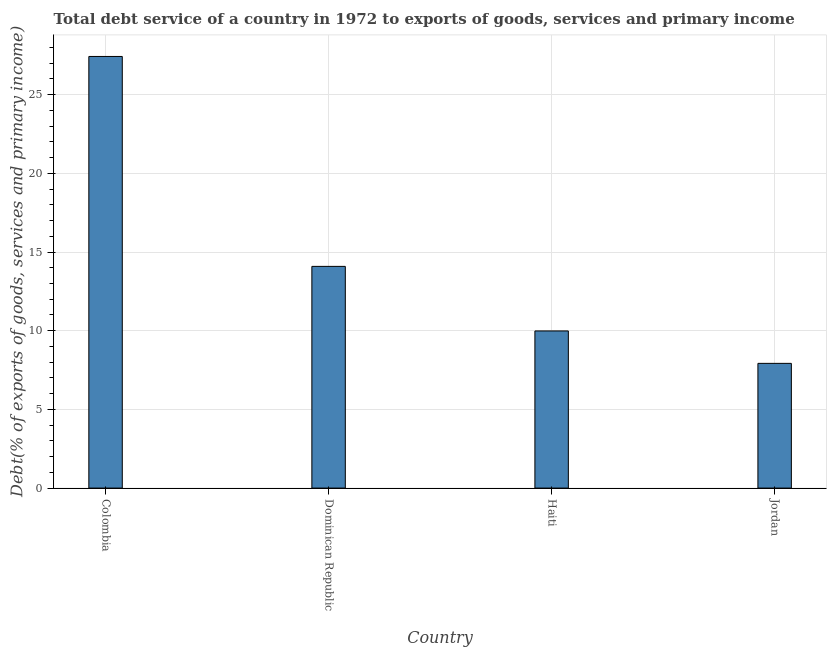Does the graph contain any zero values?
Provide a succinct answer. No. What is the title of the graph?
Make the answer very short. Total debt service of a country in 1972 to exports of goods, services and primary income. What is the label or title of the X-axis?
Your answer should be compact. Country. What is the label or title of the Y-axis?
Keep it short and to the point. Debt(% of exports of goods, services and primary income). What is the total debt service in Haiti?
Your answer should be very brief. 9.99. Across all countries, what is the maximum total debt service?
Ensure brevity in your answer.  27.43. Across all countries, what is the minimum total debt service?
Provide a succinct answer. 7.93. In which country was the total debt service minimum?
Your answer should be compact. Jordan. What is the sum of the total debt service?
Ensure brevity in your answer.  59.43. What is the difference between the total debt service in Dominican Republic and Haiti?
Your answer should be compact. 4.1. What is the average total debt service per country?
Offer a terse response. 14.86. What is the median total debt service?
Your answer should be very brief. 12.04. What is the ratio of the total debt service in Colombia to that in Jordan?
Give a very brief answer. 3.46. Is the difference between the total debt service in Colombia and Jordan greater than the difference between any two countries?
Your answer should be very brief. Yes. What is the difference between the highest and the second highest total debt service?
Your answer should be compact. 13.34. Is the sum of the total debt service in Colombia and Haiti greater than the maximum total debt service across all countries?
Your answer should be compact. Yes. What is the difference between the highest and the lowest total debt service?
Your response must be concise. 19.5. How many bars are there?
Ensure brevity in your answer.  4. Are all the bars in the graph horizontal?
Offer a terse response. No. Are the values on the major ticks of Y-axis written in scientific E-notation?
Provide a succinct answer. No. What is the Debt(% of exports of goods, services and primary income) in Colombia?
Provide a succinct answer. 27.43. What is the Debt(% of exports of goods, services and primary income) in Dominican Republic?
Your answer should be compact. 14.09. What is the Debt(% of exports of goods, services and primary income) of Haiti?
Your answer should be very brief. 9.99. What is the Debt(% of exports of goods, services and primary income) of Jordan?
Keep it short and to the point. 7.93. What is the difference between the Debt(% of exports of goods, services and primary income) in Colombia and Dominican Republic?
Keep it short and to the point. 13.34. What is the difference between the Debt(% of exports of goods, services and primary income) in Colombia and Haiti?
Offer a terse response. 17.44. What is the difference between the Debt(% of exports of goods, services and primary income) in Colombia and Jordan?
Offer a terse response. 19.5. What is the difference between the Debt(% of exports of goods, services and primary income) in Dominican Republic and Haiti?
Your answer should be compact. 4.1. What is the difference between the Debt(% of exports of goods, services and primary income) in Dominican Republic and Jordan?
Your answer should be very brief. 6.16. What is the difference between the Debt(% of exports of goods, services and primary income) in Haiti and Jordan?
Offer a very short reply. 2.06. What is the ratio of the Debt(% of exports of goods, services and primary income) in Colombia to that in Dominican Republic?
Make the answer very short. 1.95. What is the ratio of the Debt(% of exports of goods, services and primary income) in Colombia to that in Haiti?
Your response must be concise. 2.75. What is the ratio of the Debt(% of exports of goods, services and primary income) in Colombia to that in Jordan?
Provide a succinct answer. 3.46. What is the ratio of the Debt(% of exports of goods, services and primary income) in Dominican Republic to that in Haiti?
Provide a succinct answer. 1.41. What is the ratio of the Debt(% of exports of goods, services and primary income) in Dominican Republic to that in Jordan?
Provide a succinct answer. 1.78. What is the ratio of the Debt(% of exports of goods, services and primary income) in Haiti to that in Jordan?
Your answer should be compact. 1.26. 